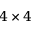<formula> <loc_0><loc_0><loc_500><loc_500>4 \times 4</formula> 